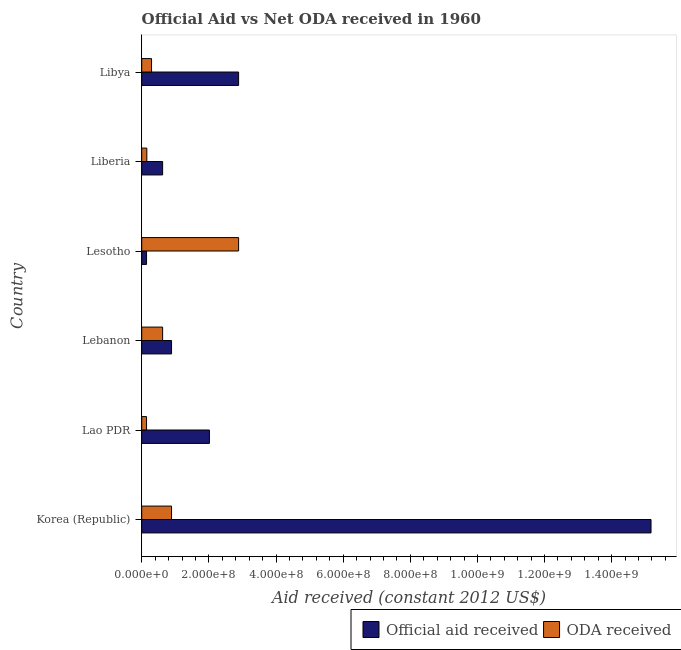How many different coloured bars are there?
Your answer should be very brief. 2. Are the number of bars per tick equal to the number of legend labels?
Provide a short and direct response. Yes. Are the number of bars on each tick of the Y-axis equal?
Offer a terse response. Yes. How many bars are there on the 3rd tick from the bottom?
Provide a succinct answer. 2. What is the label of the 4th group of bars from the top?
Offer a very short reply. Lebanon. What is the official aid received in Lesotho?
Your answer should be compact. 1.44e+07. Across all countries, what is the maximum oda received?
Provide a short and direct response. 2.89e+08. Across all countries, what is the minimum official aid received?
Ensure brevity in your answer.  1.44e+07. In which country was the oda received minimum?
Provide a succinct answer. Lao PDR. What is the total oda received in the graph?
Offer a terse response. 4.99e+08. What is the difference between the official aid received in Lao PDR and that in Liberia?
Keep it short and to the point. 1.39e+08. What is the average official aid received per country?
Make the answer very short. 3.62e+08. What is the difference between the oda received and official aid received in Korea (Republic)?
Keep it short and to the point. -1.43e+09. In how many countries, is the oda received greater than 920000000 US$?
Offer a terse response. 0. What is the ratio of the official aid received in Korea (Republic) to that in Lebanon?
Ensure brevity in your answer.  17.07. Is the official aid received in Lesotho less than that in Liberia?
Give a very brief answer. Yes. Is the difference between the oda received in Lesotho and Libya greater than the difference between the official aid received in Lesotho and Libya?
Ensure brevity in your answer.  Yes. What is the difference between the highest and the second highest official aid received?
Give a very brief answer. 1.23e+09. What is the difference between the highest and the lowest oda received?
Your answer should be compact. 2.74e+08. In how many countries, is the oda received greater than the average oda received taken over all countries?
Make the answer very short. 2. What does the 1st bar from the top in Lebanon represents?
Your answer should be very brief. ODA received. What does the 2nd bar from the bottom in Libya represents?
Keep it short and to the point. ODA received. How many bars are there?
Your response must be concise. 12. Are all the bars in the graph horizontal?
Your answer should be very brief. Yes. How many countries are there in the graph?
Keep it short and to the point. 6. How many legend labels are there?
Ensure brevity in your answer.  2. What is the title of the graph?
Provide a short and direct response. Official Aid vs Net ODA received in 1960 . What is the label or title of the X-axis?
Your answer should be very brief. Aid received (constant 2012 US$). What is the Aid received (constant 2012 US$) of Official aid received in Korea (Republic)?
Your answer should be very brief. 1.52e+09. What is the Aid received (constant 2012 US$) in ODA received in Korea (Republic)?
Your answer should be very brief. 8.88e+07. What is the Aid received (constant 2012 US$) in Official aid received in Lao PDR?
Make the answer very short. 2.02e+08. What is the Aid received (constant 2012 US$) of ODA received in Lao PDR?
Your answer should be compact. 1.44e+07. What is the Aid received (constant 2012 US$) of Official aid received in Lebanon?
Offer a very short reply. 8.88e+07. What is the Aid received (constant 2012 US$) in ODA received in Lebanon?
Give a very brief answer. 6.23e+07. What is the Aid received (constant 2012 US$) of Official aid received in Lesotho?
Keep it short and to the point. 1.44e+07. What is the Aid received (constant 2012 US$) of ODA received in Lesotho?
Make the answer very short. 2.89e+08. What is the Aid received (constant 2012 US$) of Official aid received in Liberia?
Ensure brevity in your answer.  6.23e+07. What is the Aid received (constant 2012 US$) of ODA received in Liberia?
Provide a succinct answer. 1.52e+07. What is the Aid received (constant 2012 US$) in Official aid received in Libya?
Ensure brevity in your answer.  2.89e+08. What is the Aid received (constant 2012 US$) of ODA received in Libya?
Ensure brevity in your answer.  2.92e+07. Across all countries, what is the maximum Aid received (constant 2012 US$) of Official aid received?
Give a very brief answer. 1.52e+09. Across all countries, what is the maximum Aid received (constant 2012 US$) in ODA received?
Ensure brevity in your answer.  2.89e+08. Across all countries, what is the minimum Aid received (constant 2012 US$) of Official aid received?
Your answer should be very brief. 1.44e+07. Across all countries, what is the minimum Aid received (constant 2012 US$) of ODA received?
Provide a short and direct response. 1.44e+07. What is the total Aid received (constant 2012 US$) of Official aid received in the graph?
Provide a short and direct response. 2.17e+09. What is the total Aid received (constant 2012 US$) of ODA received in the graph?
Provide a short and direct response. 4.99e+08. What is the difference between the Aid received (constant 2012 US$) of Official aid received in Korea (Republic) and that in Lao PDR?
Provide a short and direct response. 1.32e+09. What is the difference between the Aid received (constant 2012 US$) of ODA received in Korea (Republic) and that in Lao PDR?
Offer a very short reply. 7.45e+07. What is the difference between the Aid received (constant 2012 US$) of Official aid received in Korea (Republic) and that in Lebanon?
Provide a short and direct response. 1.43e+09. What is the difference between the Aid received (constant 2012 US$) in ODA received in Korea (Republic) and that in Lebanon?
Offer a terse response. 2.66e+07. What is the difference between the Aid received (constant 2012 US$) of Official aid received in Korea (Republic) and that in Lesotho?
Give a very brief answer. 1.50e+09. What is the difference between the Aid received (constant 2012 US$) in ODA received in Korea (Republic) and that in Lesotho?
Your answer should be compact. -2.00e+08. What is the difference between the Aid received (constant 2012 US$) in Official aid received in Korea (Republic) and that in Liberia?
Provide a short and direct response. 1.45e+09. What is the difference between the Aid received (constant 2012 US$) of ODA received in Korea (Republic) and that in Liberia?
Make the answer very short. 7.36e+07. What is the difference between the Aid received (constant 2012 US$) of Official aid received in Korea (Republic) and that in Libya?
Provide a succinct answer. 1.23e+09. What is the difference between the Aid received (constant 2012 US$) in ODA received in Korea (Republic) and that in Libya?
Ensure brevity in your answer.  5.96e+07. What is the difference between the Aid received (constant 2012 US$) of Official aid received in Lao PDR and that in Lebanon?
Your answer should be very brief. 1.13e+08. What is the difference between the Aid received (constant 2012 US$) in ODA received in Lao PDR and that in Lebanon?
Ensure brevity in your answer.  -4.79e+07. What is the difference between the Aid received (constant 2012 US$) of Official aid received in Lao PDR and that in Lesotho?
Ensure brevity in your answer.  1.87e+08. What is the difference between the Aid received (constant 2012 US$) of ODA received in Lao PDR and that in Lesotho?
Ensure brevity in your answer.  -2.74e+08. What is the difference between the Aid received (constant 2012 US$) of Official aid received in Lao PDR and that in Liberia?
Provide a short and direct response. 1.39e+08. What is the difference between the Aid received (constant 2012 US$) of ODA received in Lao PDR and that in Liberia?
Provide a succinct answer. -8.40e+05. What is the difference between the Aid received (constant 2012 US$) of Official aid received in Lao PDR and that in Libya?
Your answer should be compact. -8.69e+07. What is the difference between the Aid received (constant 2012 US$) in ODA received in Lao PDR and that in Libya?
Your answer should be very brief. -1.49e+07. What is the difference between the Aid received (constant 2012 US$) in Official aid received in Lebanon and that in Lesotho?
Make the answer very short. 7.45e+07. What is the difference between the Aid received (constant 2012 US$) in ODA received in Lebanon and that in Lesotho?
Offer a very short reply. -2.26e+08. What is the difference between the Aid received (constant 2012 US$) of Official aid received in Lebanon and that in Liberia?
Provide a succinct answer. 2.66e+07. What is the difference between the Aid received (constant 2012 US$) in ODA received in Lebanon and that in Liberia?
Offer a terse response. 4.71e+07. What is the difference between the Aid received (constant 2012 US$) of Official aid received in Lebanon and that in Libya?
Offer a terse response. -2.00e+08. What is the difference between the Aid received (constant 2012 US$) in ODA received in Lebanon and that in Libya?
Keep it short and to the point. 3.30e+07. What is the difference between the Aid received (constant 2012 US$) of Official aid received in Lesotho and that in Liberia?
Your response must be concise. -4.79e+07. What is the difference between the Aid received (constant 2012 US$) of ODA received in Lesotho and that in Liberia?
Offer a very short reply. 2.73e+08. What is the difference between the Aid received (constant 2012 US$) of Official aid received in Lesotho and that in Libya?
Ensure brevity in your answer.  -2.74e+08. What is the difference between the Aid received (constant 2012 US$) of ODA received in Lesotho and that in Libya?
Offer a terse response. 2.59e+08. What is the difference between the Aid received (constant 2012 US$) in Official aid received in Liberia and that in Libya?
Provide a short and direct response. -2.26e+08. What is the difference between the Aid received (constant 2012 US$) of ODA received in Liberia and that in Libya?
Provide a short and direct response. -1.40e+07. What is the difference between the Aid received (constant 2012 US$) of Official aid received in Korea (Republic) and the Aid received (constant 2012 US$) of ODA received in Lao PDR?
Give a very brief answer. 1.50e+09. What is the difference between the Aid received (constant 2012 US$) of Official aid received in Korea (Republic) and the Aid received (constant 2012 US$) of ODA received in Lebanon?
Keep it short and to the point. 1.45e+09. What is the difference between the Aid received (constant 2012 US$) of Official aid received in Korea (Republic) and the Aid received (constant 2012 US$) of ODA received in Lesotho?
Make the answer very short. 1.23e+09. What is the difference between the Aid received (constant 2012 US$) in Official aid received in Korea (Republic) and the Aid received (constant 2012 US$) in ODA received in Liberia?
Give a very brief answer. 1.50e+09. What is the difference between the Aid received (constant 2012 US$) in Official aid received in Korea (Republic) and the Aid received (constant 2012 US$) in ODA received in Libya?
Make the answer very short. 1.49e+09. What is the difference between the Aid received (constant 2012 US$) of Official aid received in Lao PDR and the Aid received (constant 2012 US$) of ODA received in Lebanon?
Keep it short and to the point. 1.39e+08. What is the difference between the Aid received (constant 2012 US$) of Official aid received in Lao PDR and the Aid received (constant 2012 US$) of ODA received in Lesotho?
Your answer should be very brief. -8.69e+07. What is the difference between the Aid received (constant 2012 US$) in Official aid received in Lao PDR and the Aid received (constant 2012 US$) in ODA received in Liberia?
Your answer should be compact. 1.86e+08. What is the difference between the Aid received (constant 2012 US$) of Official aid received in Lao PDR and the Aid received (constant 2012 US$) of ODA received in Libya?
Keep it short and to the point. 1.72e+08. What is the difference between the Aid received (constant 2012 US$) of Official aid received in Lebanon and the Aid received (constant 2012 US$) of ODA received in Lesotho?
Keep it short and to the point. -2.00e+08. What is the difference between the Aid received (constant 2012 US$) in Official aid received in Lebanon and the Aid received (constant 2012 US$) in ODA received in Liberia?
Provide a short and direct response. 7.36e+07. What is the difference between the Aid received (constant 2012 US$) of Official aid received in Lebanon and the Aid received (constant 2012 US$) of ODA received in Libya?
Make the answer very short. 5.96e+07. What is the difference between the Aid received (constant 2012 US$) in Official aid received in Lesotho and the Aid received (constant 2012 US$) in ODA received in Liberia?
Offer a very short reply. -8.40e+05. What is the difference between the Aid received (constant 2012 US$) of Official aid received in Lesotho and the Aid received (constant 2012 US$) of ODA received in Libya?
Provide a succinct answer. -1.49e+07. What is the difference between the Aid received (constant 2012 US$) in Official aid received in Liberia and the Aid received (constant 2012 US$) in ODA received in Libya?
Your response must be concise. 3.30e+07. What is the average Aid received (constant 2012 US$) of Official aid received per country?
Offer a terse response. 3.62e+08. What is the average Aid received (constant 2012 US$) in ODA received per country?
Provide a succinct answer. 8.31e+07. What is the difference between the Aid received (constant 2012 US$) of Official aid received and Aid received (constant 2012 US$) of ODA received in Korea (Republic)?
Your answer should be very brief. 1.43e+09. What is the difference between the Aid received (constant 2012 US$) in Official aid received and Aid received (constant 2012 US$) in ODA received in Lao PDR?
Make the answer very short. 1.87e+08. What is the difference between the Aid received (constant 2012 US$) in Official aid received and Aid received (constant 2012 US$) in ODA received in Lebanon?
Provide a succinct answer. 2.66e+07. What is the difference between the Aid received (constant 2012 US$) in Official aid received and Aid received (constant 2012 US$) in ODA received in Lesotho?
Your response must be concise. -2.74e+08. What is the difference between the Aid received (constant 2012 US$) of Official aid received and Aid received (constant 2012 US$) of ODA received in Liberia?
Provide a short and direct response. 4.71e+07. What is the difference between the Aid received (constant 2012 US$) in Official aid received and Aid received (constant 2012 US$) in ODA received in Libya?
Ensure brevity in your answer.  2.59e+08. What is the ratio of the Aid received (constant 2012 US$) in Official aid received in Korea (Republic) to that in Lao PDR?
Make the answer very short. 7.52. What is the ratio of the Aid received (constant 2012 US$) of ODA received in Korea (Republic) to that in Lao PDR?
Give a very brief answer. 6.18. What is the ratio of the Aid received (constant 2012 US$) in Official aid received in Korea (Republic) to that in Lebanon?
Your answer should be compact. 17.08. What is the ratio of the Aid received (constant 2012 US$) in ODA received in Korea (Republic) to that in Lebanon?
Provide a short and direct response. 1.43. What is the ratio of the Aid received (constant 2012 US$) in Official aid received in Korea (Republic) to that in Lesotho?
Offer a very short reply. 105.5. What is the ratio of the Aid received (constant 2012 US$) in ODA received in Korea (Republic) to that in Lesotho?
Provide a succinct answer. 0.31. What is the ratio of the Aid received (constant 2012 US$) in Official aid received in Korea (Republic) to that in Liberia?
Keep it short and to the point. 24.36. What is the ratio of the Aid received (constant 2012 US$) of ODA received in Korea (Republic) to that in Liberia?
Offer a terse response. 5.84. What is the ratio of the Aid received (constant 2012 US$) of Official aid received in Korea (Republic) to that in Libya?
Give a very brief answer. 5.26. What is the ratio of the Aid received (constant 2012 US$) in ODA received in Korea (Republic) to that in Libya?
Offer a very short reply. 3.04. What is the ratio of the Aid received (constant 2012 US$) in Official aid received in Lao PDR to that in Lebanon?
Ensure brevity in your answer.  2.27. What is the ratio of the Aid received (constant 2012 US$) in ODA received in Lao PDR to that in Lebanon?
Make the answer very short. 0.23. What is the ratio of the Aid received (constant 2012 US$) in Official aid received in Lao PDR to that in Lesotho?
Give a very brief answer. 14.03. What is the ratio of the Aid received (constant 2012 US$) of ODA received in Lao PDR to that in Lesotho?
Your answer should be very brief. 0.05. What is the ratio of the Aid received (constant 2012 US$) of Official aid received in Lao PDR to that in Liberia?
Provide a succinct answer. 3.24. What is the ratio of the Aid received (constant 2012 US$) in ODA received in Lao PDR to that in Liberia?
Offer a terse response. 0.94. What is the ratio of the Aid received (constant 2012 US$) in Official aid received in Lao PDR to that in Libya?
Ensure brevity in your answer.  0.7. What is the ratio of the Aid received (constant 2012 US$) in ODA received in Lao PDR to that in Libya?
Offer a terse response. 0.49. What is the ratio of the Aid received (constant 2012 US$) of Official aid received in Lebanon to that in Lesotho?
Make the answer very short. 6.18. What is the ratio of the Aid received (constant 2012 US$) in ODA received in Lebanon to that in Lesotho?
Make the answer very short. 0.22. What is the ratio of the Aid received (constant 2012 US$) in Official aid received in Lebanon to that in Liberia?
Provide a short and direct response. 1.43. What is the ratio of the Aid received (constant 2012 US$) of ODA received in Lebanon to that in Liberia?
Give a very brief answer. 4.09. What is the ratio of the Aid received (constant 2012 US$) of Official aid received in Lebanon to that in Libya?
Give a very brief answer. 0.31. What is the ratio of the Aid received (constant 2012 US$) in ODA received in Lebanon to that in Libya?
Offer a very short reply. 2.13. What is the ratio of the Aid received (constant 2012 US$) of Official aid received in Lesotho to that in Liberia?
Give a very brief answer. 0.23. What is the ratio of the Aid received (constant 2012 US$) of ODA received in Lesotho to that in Liberia?
Provide a short and direct response. 18.96. What is the ratio of the Aid received (constant 2012 US$) in Official aid received in Lesotho to that in Libya?
Your answer should be compact. 0.05. What is the ratio of the Aid received (constant 2012 US$) in ODA received in Lesotho to that in Libya?
Keep it short and to the point. 9.87. What is the ratio of the Aid received (constant 2012 US$) in Official aid received in Liberia to that in Libya?
Your answer should be compact. 0.22. What is the ratio of the Aid received (constant 2012 US$) of ODA received in Liberia to that in Libya?
Your answer should be very brief. 0.52. What is the difference between the highest and the second highest Aid received (constant 2012 US$) of Official aid received?
Make the answer very short. 1.23e+09. What is the difference between the highest and the second highest Aid received (constant 2012 US$) in ODA received?
Provide a succinct answer. 2.00e+08. What is the difference between the highest and the lowest Aid received (constant 2012 US$) in Official aid received?
Give a very brief answer. 1.50e+09. What is the difference between the highest and the lowest Aid received (constant 2012 US$) of ODA received?
Ensure brevity in your answer.  2.74e+08. 